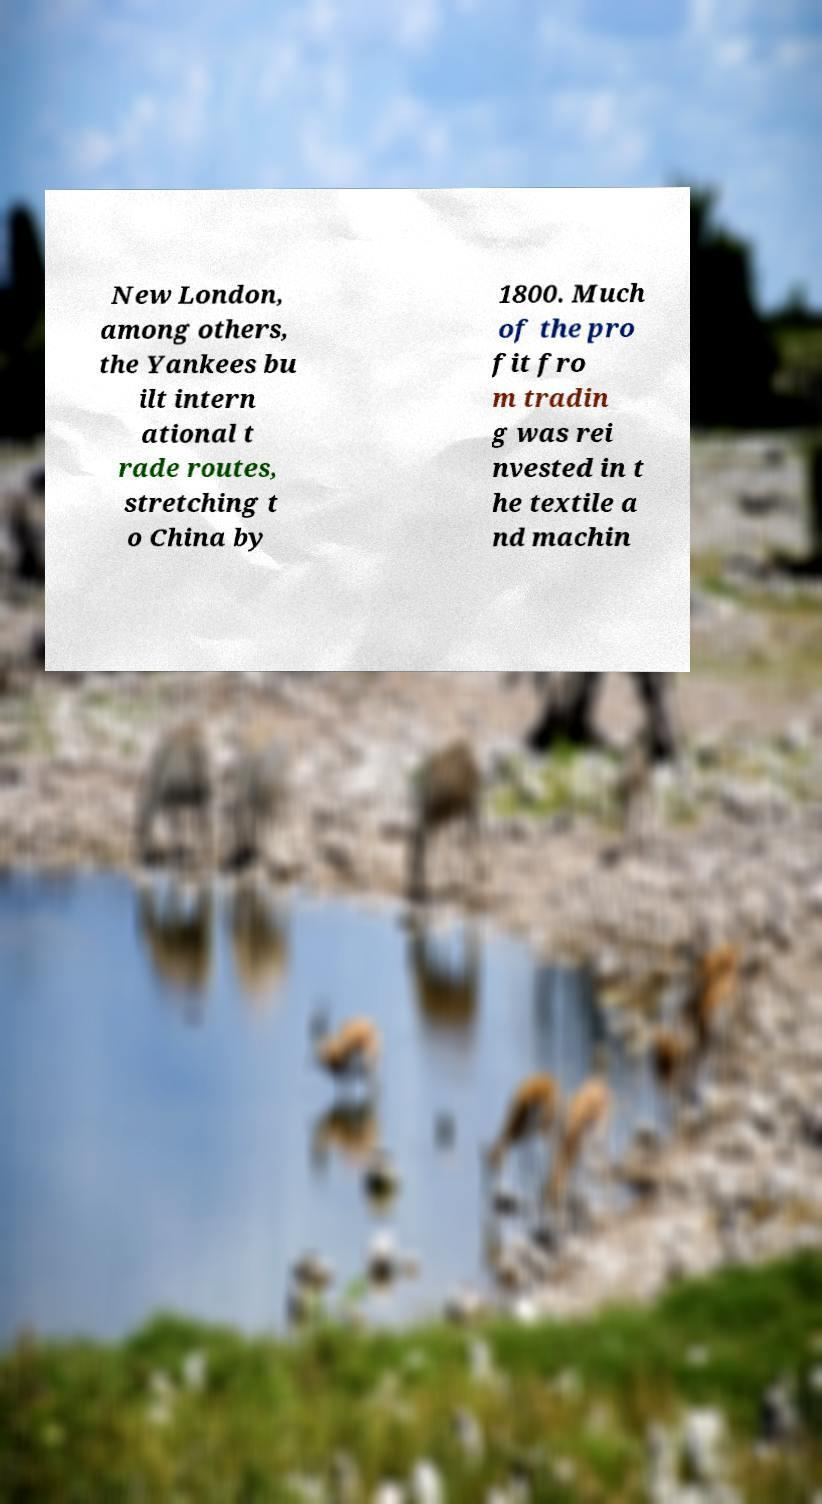Could you assist in decoding the text presented in this image and type it out clearly? New London, among others, the Yankees bu ilt intern ational t rade routes, stretching t o China by 1800. Much of the pro fit fro m tradin g was rei nvested in t he textile a nd machin 